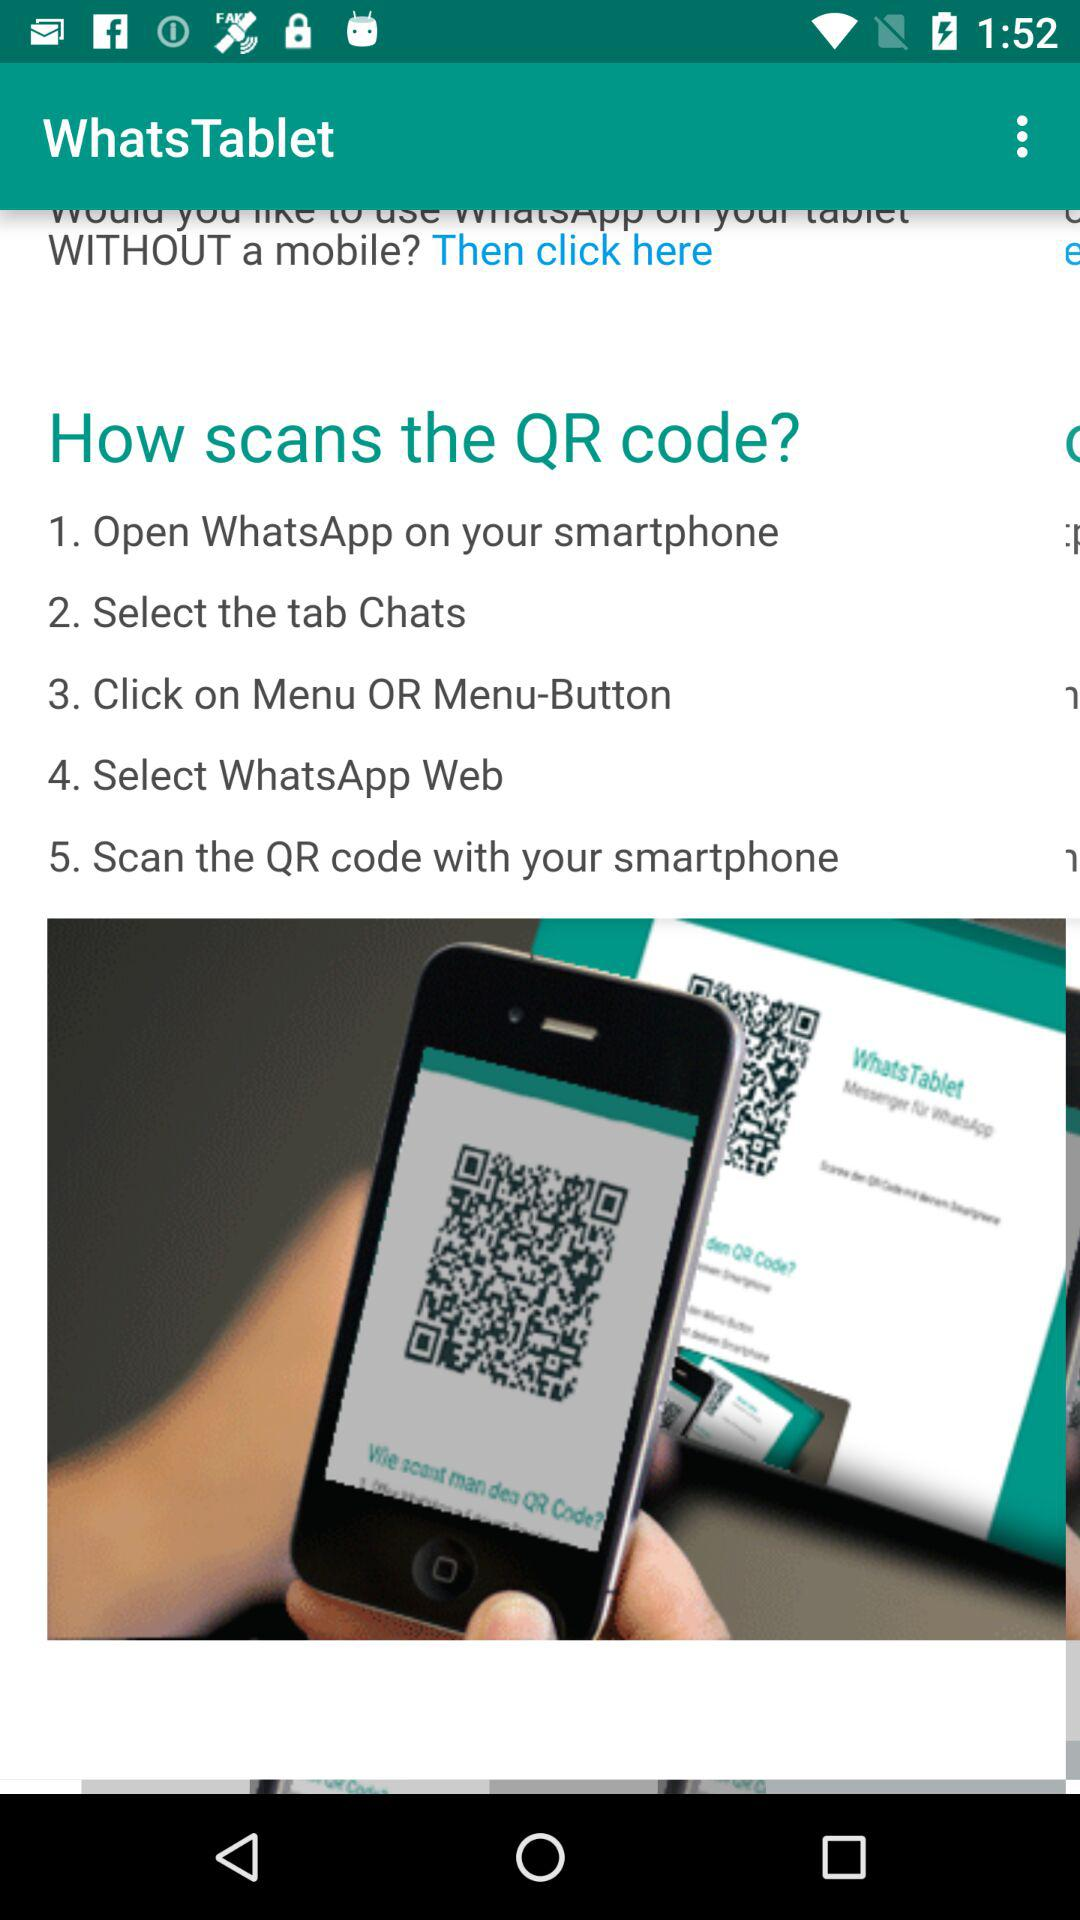How many steps are there to scan the QR code?
Answer the question using a single word or phrase. 5 